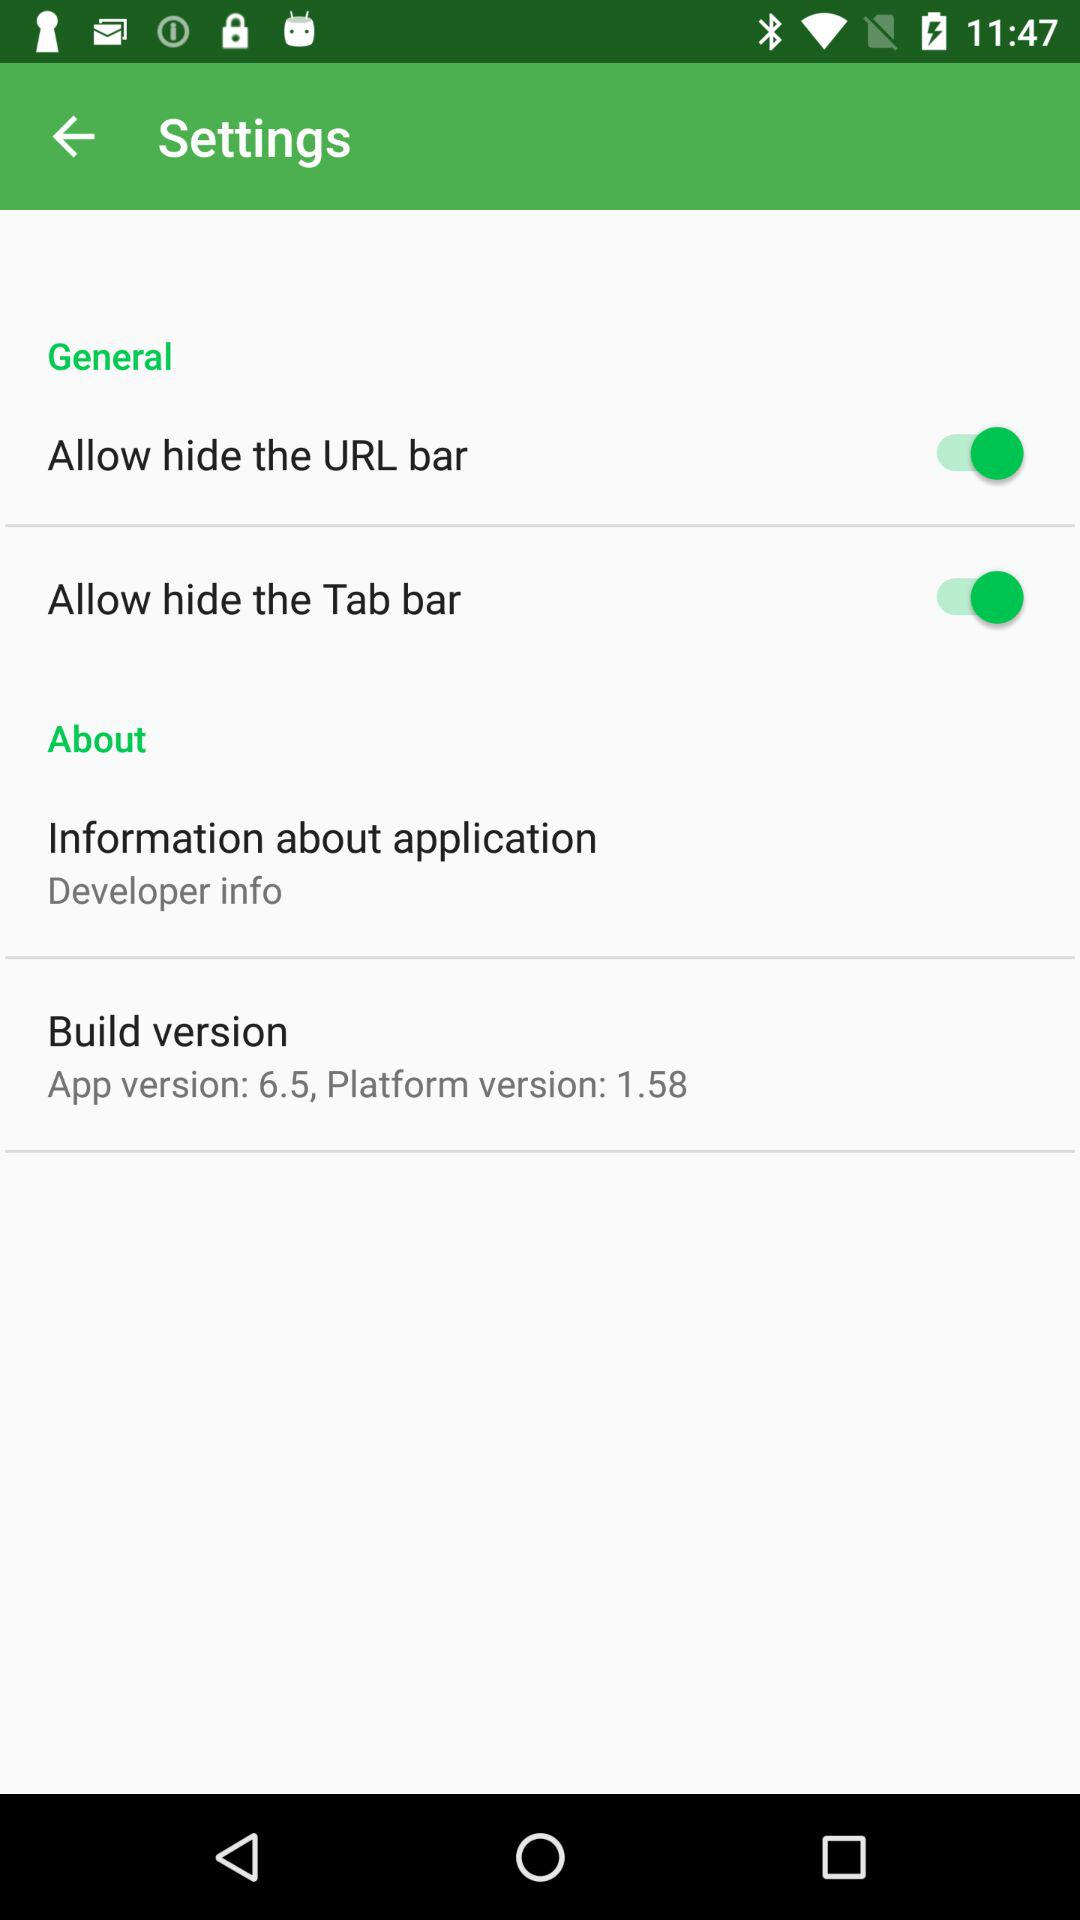How many items are in the settings menu?
Answer the question using a single word or phrase. 4 